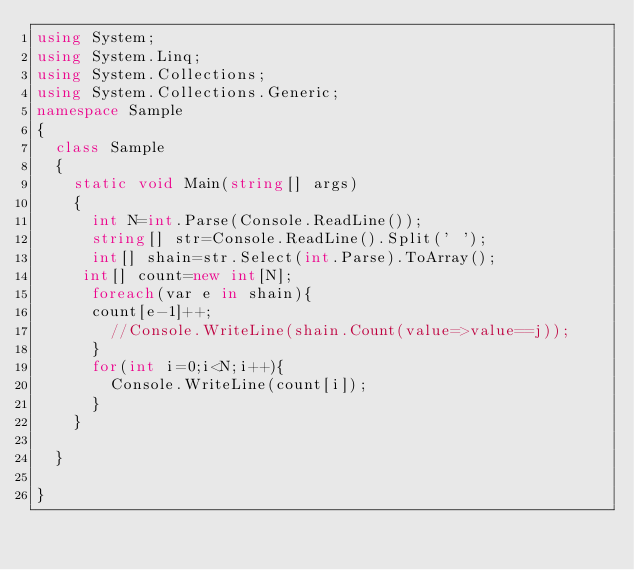<code> <loc_0><loc_0><loc_500><loc_500><_C#_>using System;
using System.Linq;
using System.Collections;
using System.Collections.Generic;
namespace Sample
{
  class Sample
  {
    static void Main(string[] args)
    {
      int N=int.Parse(Console.ReadLine());
      string[] str=Console.ReadLine().Split(' ');
      int[] shain=str.Select(int.Parse).ToArray();
 	 int[] count=new int[N];      
      foreach(var e in shain){
      count[e-1]++;        
        //Console.WriteLine(shain.Count(value=>value==j));
      }
      for(int i=0;i<N;i++){
        Console.WriteLine(count[i]);
      }
    }
    
  }

}

</code> 